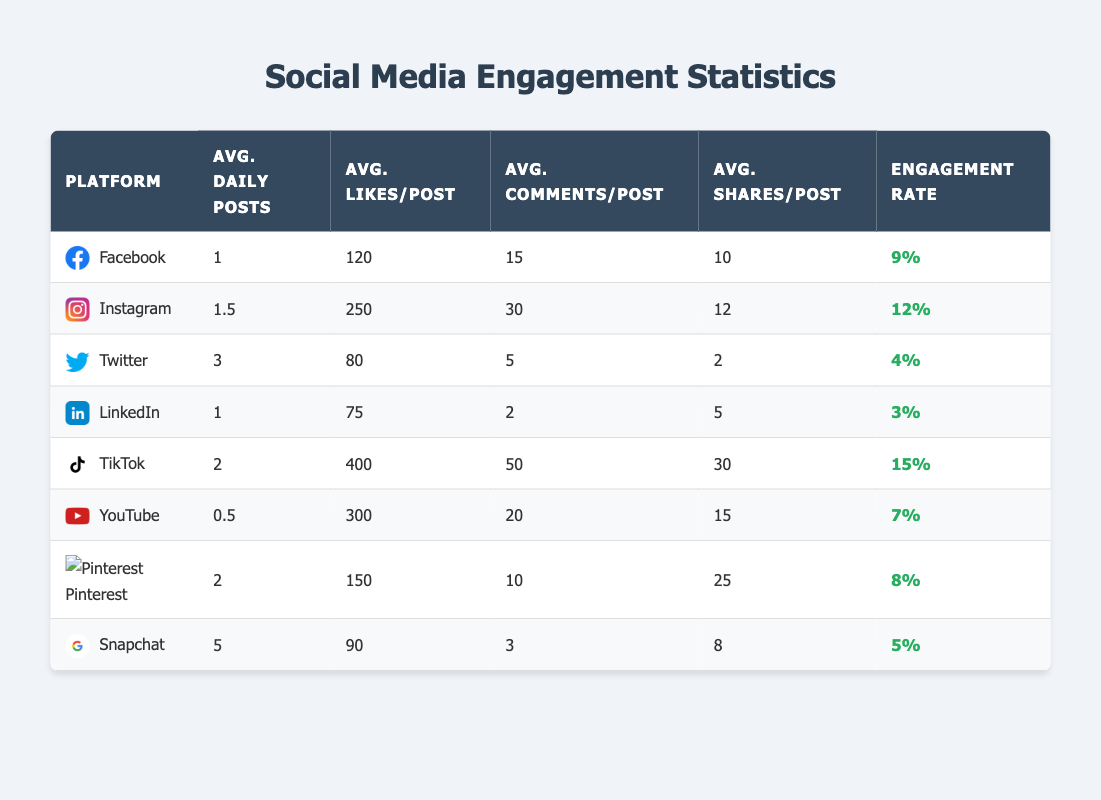What is the platform with the highest engagement rate? By examining the 'Engagement Rate' column for each platform, I see that TikTok has the highest engagement rate at 0.15.
Answer: TikTok How many likes per post does Instagram receive on average? According to the 'Average Likes per Post' column for Instagram, it shows 250 likes.
Answer: 250 What is the average total number of shares from Snapchat posts per day? We can find the average number of shares per post for Snapchat, which is 8, and since Snapchat averages 5 daily posts, multiplying gives us a total of 40 shares per day (5 * 8 = 40).
Answer: 40 Which platform has the lowest average comments per post? By looking at the 'Average Comments per Post' column, I see LinkedIn has the lowest average comments per post at 2.
Answer: LinkedIn Is TikTok's engagement rate higher than that of Facebook? Comparing the engagement rates, TikTok has an engagement rate of 0.15 and Facebook has 0.09, which means TikTok's engagement rate is indeed higher than Facebook's.
Answer: Yes What is the average engagement rate of all platforms? To calculate the average engagement rate, I sum up all engagement rates (0.09 + 0.12 + 0.04 + 0.03 + 0.15 + 0.07 + 0.08 + 0.05), which totals 0.63, and then dividing by 8 platforms gives an average engagement rate of 0.07875, rounded to 0.08.
Answer: 0.08 How many more average daily posts does Twitter have compared to LinkedIn? From the 'Average Daily Posts' column, Twitter has 3 posts while LinkedIn has 1 post. The difference of 3 - 1 equals 2, meaning Twitter has 2 more average daily posts than LinkedIn.
Answer: 2 Which platform has the highest average likes per post, and how does it compare to the overall average? TikTok has the highest average likes per post at 400. To find out how it compares, we look at the total likes averaged across all platforms, which is (120 + 250 + 80 + 75 + 400 + 300 + 150 + 90) / 8, resulting in an overall average like per post of 195. TikTok's likes significantly exceed this average.
Answer: TikTok, significantly higher What is the total average number of posts across all platforms? Adding the average daily posts for all platforms (1 + 1.5 + 3 + 1 + 2 + 0.5 + 2 + 5) gives a total of 16, and dividing by 8 platforms results in an average of 2 posts per platform.
Answer: 2 